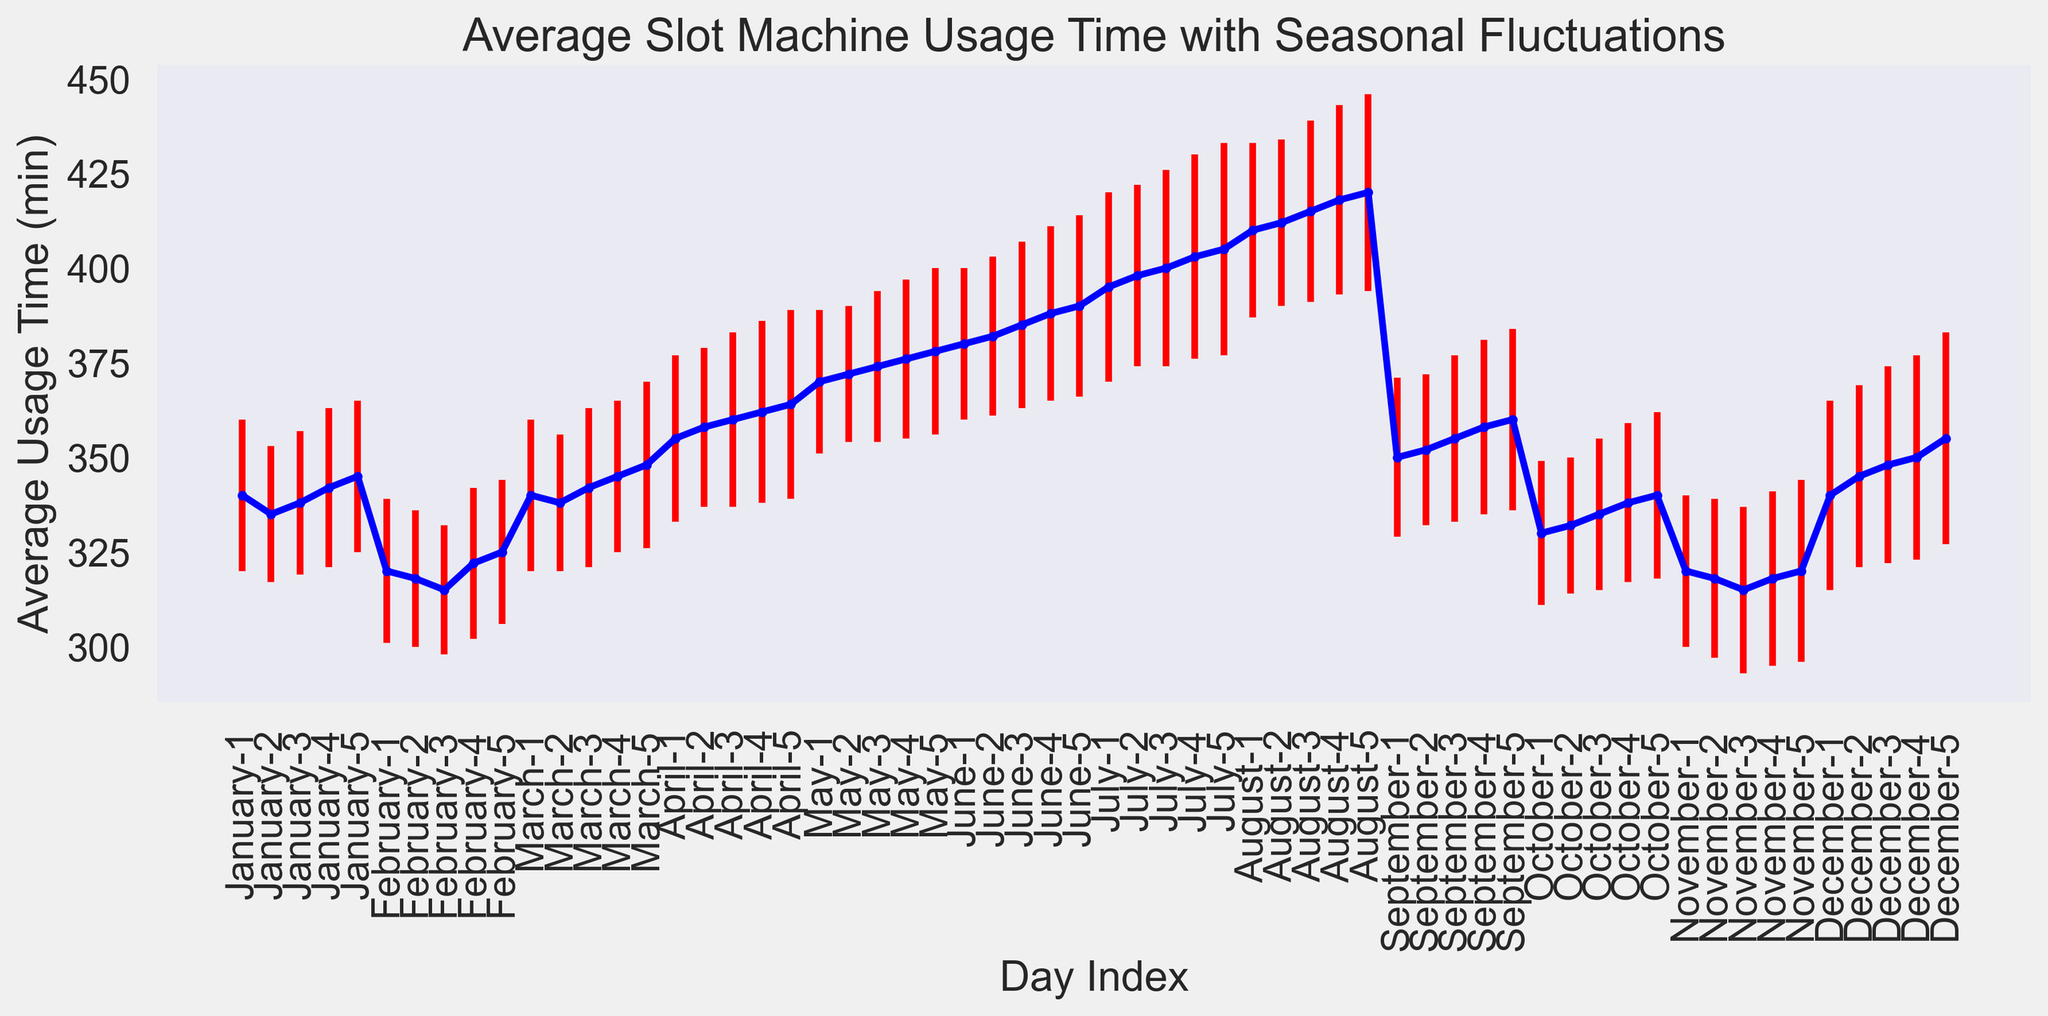How does the average slot machine usage time in July compare to that in January? To compare the average slot machine usage time in July and January, look at the data points for both months. In January, usage times are between 335 and 345 minutes, while in July, they range from 395 to 405 minutes. Thus, usage times are higher in July.
Answer: July's usage time is higher What is the overall trend of average slot machine usage time from January to December? To determine the trend, examine the general direction of the data points across the months. The plot shows an upward trend from January to July, a slight drop in September, another drop in October and November, and then a rise in December.
Answer: Overall upward trend with some fluctuations Which month has the highest average usage time and what is that time? To identify the month with the highest average usage time, look for the peak on the plot. The highest point is in August, with an average usage time of approximately 420 minutes.
Answer: August, 420 minutes Which month has the most significant variation in slot machine usage time? To find the month with the most significant variation, look for the longest error bars on the plot. December has the longest error bars, indicating the highest standard deviation.
Answer: December What is the difference in average usage time between the beginning and end of the plot? Locate the first and last data points on the plot. The first point (January 1) has an average usage time of 340 minutes, and the last point (December 5) has an average of 355 minutes. The difference is 355 - 340 = 15 minutes.
Answer: 15 minutes What season appears to have the lowest average slot machine usage? Group the months into seasons: Winter (Dec-Feb), Spring (Mar-May), Summer (Jun-Aug), and Fall (Sept-Nov). The plot shows lower average usage times in Winter (December to February).
Answer: Winter How does the standard deviation in slot machine usage time compare between March and October? Compare the lengths of the error bars for March and October. March's error bars are longer, indicating a higher standard deviation than October's.
Answer: March has higher standard deviation Which month has the steepest increase in average usage time? Look for the steepest upward slope on the plot. The most rapid increase occurs between April and May.
Answer: April to May On which day of the year does the average usage time peak? Identify the highest single data point on the plot. The peak usage time is on August 5 with 420 minutes.
Answer: August 5 Which month shows the largest decrease in average usage time compared to the previous month? Check the plot for the most significant downward slope when moving from one month to the next. This occurs between August and September.
Answer: August to September 